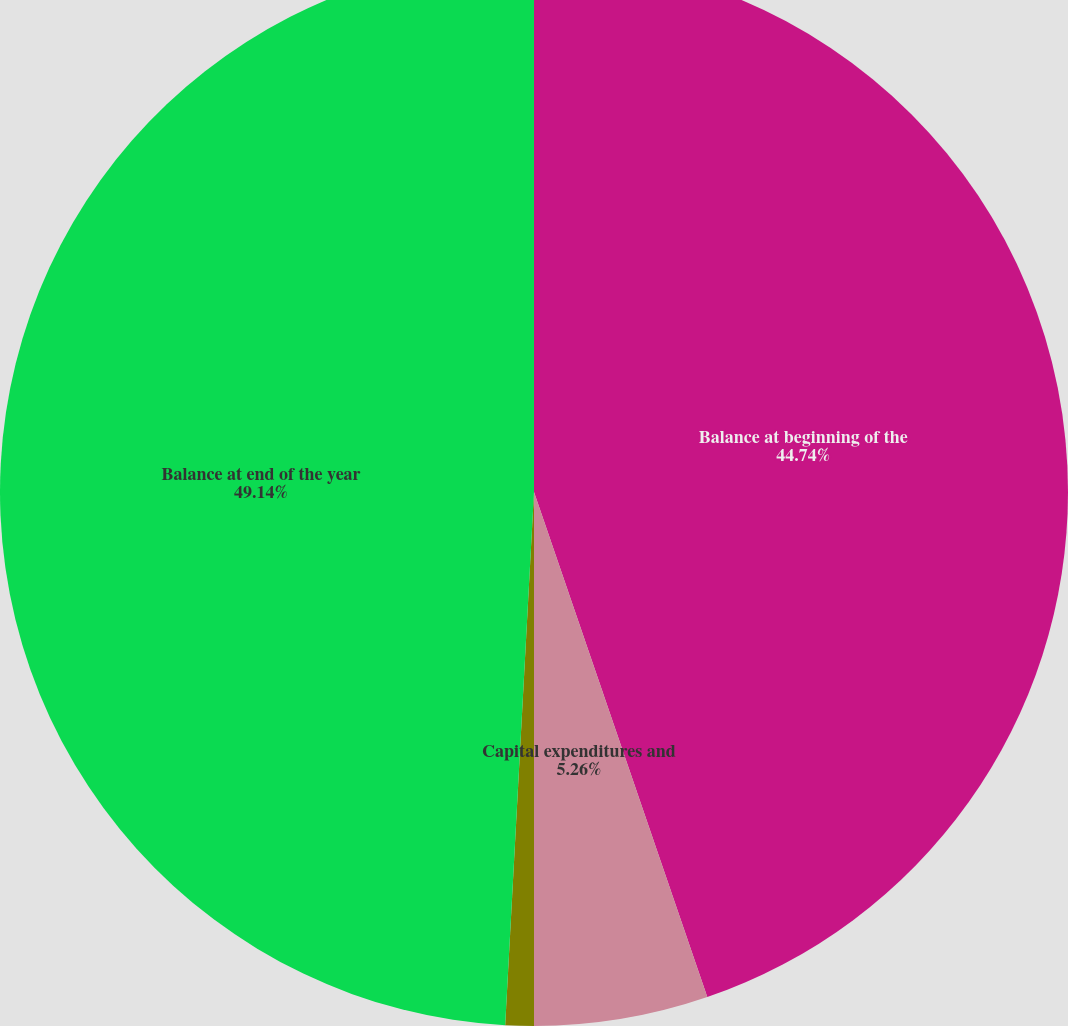Convert chart. <chart><loc_0><loc_0><loc_500><loc_500><pie_chart><fcel>Balance at beginning of the<fcel>Capital expenditures and<fcel>Real estate sold<fcel>Balance at end of the year<nl><fcel>44.74%<fcel>5.26%<fcel>0.86%<fcel>49.14%<nl></chart> 